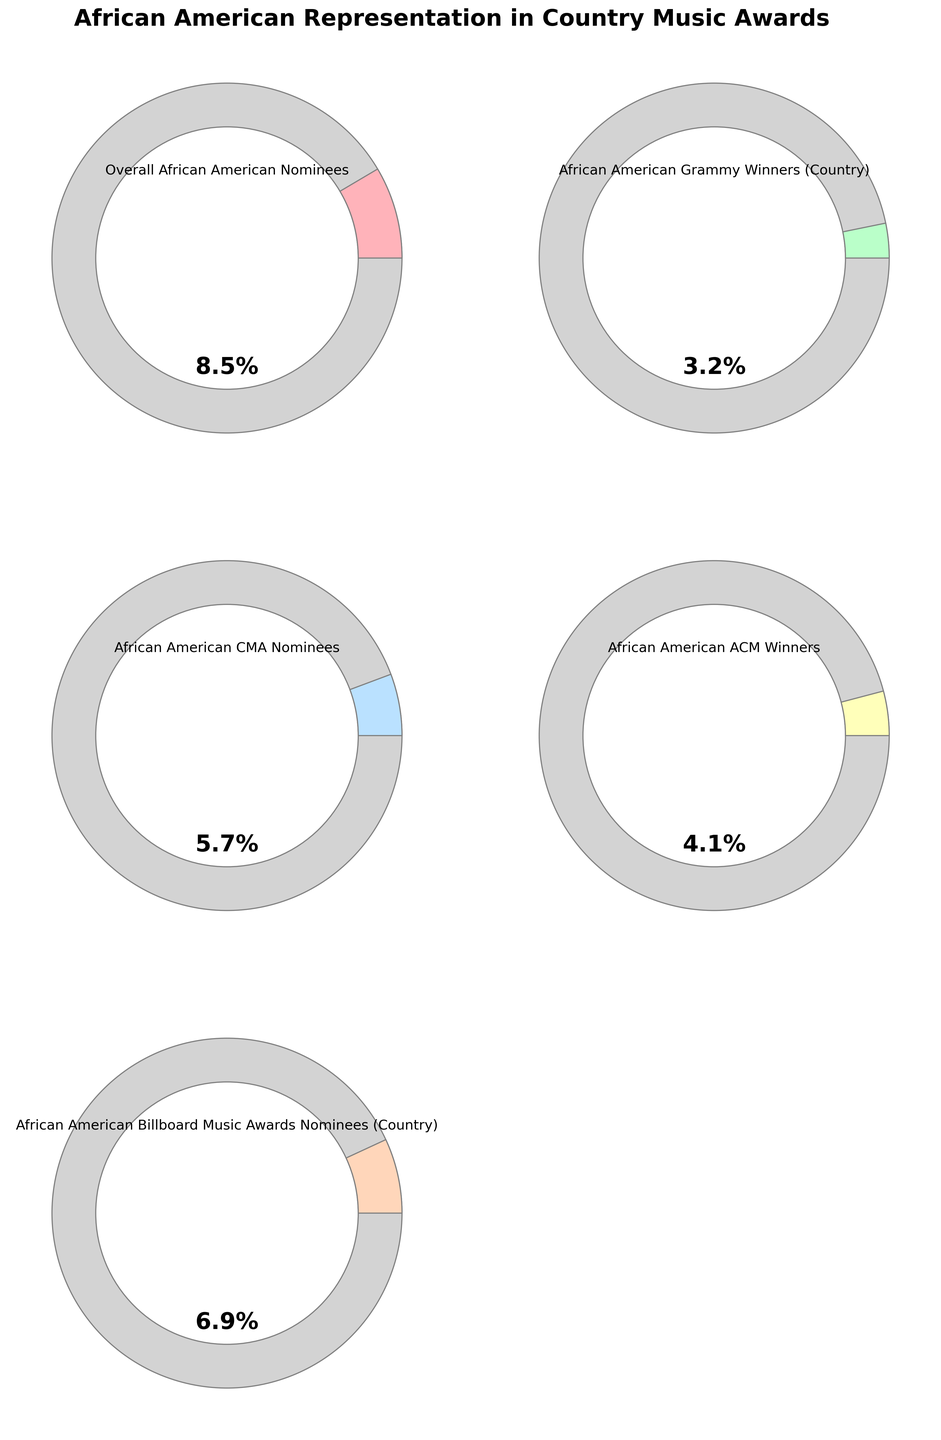Who has the highest percentage among the categories? The category "Overall African American Nominees" has a gauge reaching the highest percentage value.
Answer: Overall African American Nominees What is the title of the figure? The title is located at the top of the figure. It reads "African American Representation in Country Music Awards".
Answer: African American Representation in Country Music Awards Which category shows the lowest percentage? The gauge for "African American Grammy Winners (Country)" covers the least area, indicating this category has the lowest percentage.
Answer: African American Grammy Winners (Country) How does the percentage of African American ACM Winners compare to African American CMA Nominees? By comparing both gauges, "African American ACM Winners" have a lower percentage (4.1%) than "African American CMA Nominees" (5.7%).
Answer: African American ACM Winners is lower than African American CMA Nominees What is the total percentage for the categories combined? Summing up all percentages: 8.5% + 3.2% + 5.7% + 4.1% + 6.9% = 28.4%.
Answer: 28.4% What is the difference in percentage between "African American Billboard Music Awards Nominees (Country)" and "Overall African American Nominees"? The difference is calculated by subtracting 6.9% from 8.5%, which is 1.6%.
Answer: 1.6% Are there any categories with similar percentages? The gauges for "African American CMA Nominees" and "African American Billboard Music Awards Nominees (Country)" have relatively close percentages (5.7% and 6.9%, respectively).
Answer: Yes, African American CMA Nominees and African American Billboard Music Awards Nominees (Country) Which color represents the percentage for "African American Grammy Winners (Country)"? The gauge for "African American Grammy Winners (Country)" has a color similar to light green.
Answer: Light green 